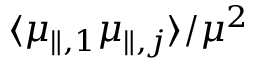Convert formula to latex. <formula><loc_0><loc_0><loc_500><loc_500>\langle \mu _ { \| , 1 } \mu _ { \| , j } \rangle / \mu ^ { 2 }</formula> 